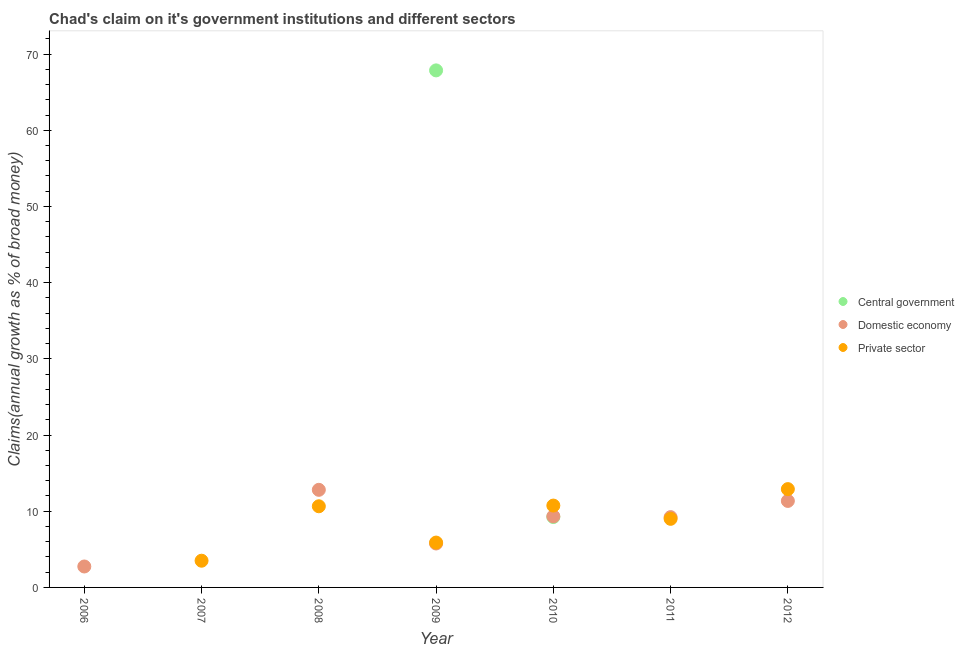Is the number of dotlines equal to the number of legend labels?
Offer a very short reply. No. Across all years, what is the maximum percentage of claim on the central government?
Make the answer very short. 67.86. In which year was the percentage of claim on the domestic economy maximum?
Offer a terse response. 2008. What is the total percentage of claim on the domestic economy in the graph?
Give a very brief answer. 51.23. What is the difference between the percentage of claim on the private sector in 2011 and that in 2012?
Your response must be concise. -3.9. What is the difference between the percentage of claim on the central government in 2010 and the percentage of claim on the domestic economy in 2008?
Your answer should be compact. -3.57. What is the average percentage of claim on the central government per year?
Give a very brief answer. 11.01. In the year 2009, what is the difference between the percentage of claim on the domestic economy and percentage of claim on the private sector?
Offer a very short reply. -0.12. In how many years, is the percentage of claim on the central government greater than 10 %?
Offer a very short reply. 1. What is the ratio of the percentage of claim on the private sector in 2008 to that in 2012?
Make the answer very short. 0.83. Is the percentage of claim on the domestic economy in 2006 less than that in 2009?
Make the answer very short. Yes. Is the difference between the percentage of claim on the domestic economy in 2009 and 2012 greater than the difference between the percentage of claim on the private sector in 2009 and 2012?
Offer a very short reply. Yes. What is the difference between the highest and the second highest percentage of claim on the domestic economy?
Your answer should be very brief. 1.46. What is the difference between the highest and the lowest percentage of claim on the central government?
Your response must be concise. 67.86. Is the percentage of claim on the domestic economy strictly greater than the percentage of claim on the private sector over the years?
Your answer should be very brief. No. Is the percentage of claim on the domestic economy strictly less than the percentage of claim on the central government over the years?
Offer a very short reply. No. What is the difference between two consecutive major ticks on the Y-axis?
Ensure brevity in your answer.  10. Where does the legend appear in the graph?
Offer a very short reply. Center right. What is the title of the graph?
Provide a short and direct response. Chad's claim on it's government institutions and different sectors. What is the label or title of the X-axis?
Offer a very short reply. Year. What is the label or title of the Y-axis?
Offer a very short reply. Claims(annual growth as % of broad money). What is the Claims(annual growth as % of broad money) of Central government in 2006?
Keep it short and to the point. 0. What is the Claims(annual growth as % of broad money) of Domestic economy in 2006?
Ensure brevity in your answer.  2.75. What is the Claims(annual growth as % of broad money) of Private sector in 2006?
Ensure brevity in your answer.  0. What is the Claims(annual growth as % of broad money) in Central government in 2007?
Your answer should be compact. 0. What is the Claims(annual growth as % of broad money) of Private sector in 2007?
Provide a succinct answer. 3.51. What is the Claims(annual growth as % of broad money) in Domestic economy in 2008?
Give a very brief answer. 12.81. What is the Claims(annual growth as % of broad money) of Private sector in 2008?
Offer a very short reply. 10.65. What is the Claims(annual growth as % of broad money) in Central government in 2009?
Provide a short and direct response. 67.86. What is the Claims(annual growth as % of broad money) in Domestic economy in 2009?
Give a very brief answer. 5.77. What is the Claims(annual growth as % of broad money) of Private sector in 2009?
Your response must be concise. 5.89. What is the Claims(annual growth as % of broad money) in Central government in 2010?
Offer a terse response. 9.24. What is the Claims(annual growth as % of broad money) of Domestic economy in 2010?
Ensure brevity in your answer.  9.33. What is the Claims(annual growth as % of broad money) of Private sector in 2010?
Give a very brief answer. 10.74. What is the Claims(annual growth as % of broad money) of Central government in 2011?
Provide a succinct answer. 0. What is the Claims(annual growth as % of broad money) in Domestic economy in 2011?
Make the answer very short. 9.22. What is the Claims(annual growth as % of broad money) in Private sector in 2011?
Offer a very short reply. 9. What is the Claims(annual growth as % of broad money) of Central government in 2012?
Your answer should be compact. 0. What is the Claims(annual growth as % of broad money) in Domestic economy in 2012?
Your answer should be very brief. 11.35. What is the Claims(annual growth as % of broad money) of Private sector in 2012?
Make the answer very short. 12.9. Across all years, what is the maximum Claims(annual growth as % of broad money) of Central government?
Give a very brief answer. 67.86. Across all years, what is the maximum Claims(annual growth as % of broad money) in Domestic economy?
Offer a very short reply. 12.81. Across all years, what is the maximum Claims(annual growth as % of broad money) in Private sector?
Your answer should be very brief. 12.9. Across all years, what is the minimum Claims(annual growth as % of broad money) in Domestic economy?
Ensure brevity in your answer.  0. What is the total Claims(annual growth as % of broad money) in Central government in the graph?
Keep it short and to the point. 77.09. What is the total Claims(annual growth as % of broad money) of Domestic economy in the graph?
Provide a succinct answer. 51.23. What is the total Claims(annual growth as % of broad money) in Private sector in the graph?
Offer a very short reply. 52.69. What is the difference between the Claims(annual growth as % of broad money) in Domestic economy in 2006 and that in 2008?
Ensure brevity in your answer.  -10.06. What is the difference between the Claims(annual growth as % of broad money) of Domestic economy in 2006 and that in 2009?
Your answer should be very brief. -3.02. What is the difference between the Claims(annual growth as % of broad money) in Domestic economy in 2006 and that in 2010?
Offer a very short reply. -6.58. What is the difference between the Claims(annual growth as % of broad money) in Domestic economy in 2006 and that in 2011?
Offer a terse response. -6.48. What is the difference between the Claims(annual growth as % of broad money) in Domestic economy in 2006 and that in 2012?
Your answer should be very brief. -8.6. What is the difference between the Claims(annual growth as % of broad money) in Private sector in 2007 and that in 2008?
Your answer should be compact. -7.14. What is the difference between the Claims(annual growth as % of broad money) in Private sector in 2007 and that in 2009?
Provide a short and direct response. -2.38. What is the difference between the Claims(annual growth as % of broad money) of Private sector in 2007 and that in 2010?
Offer a very short reply. -7.24. What is the difference between the Claims(annual growth as % of broad money) in Private sector in 2007 and that in 2011?
Offer a very short reply. -5.5. What is the difference between the Claims(annual growth as % of broad money) of Private sector in 2007 and that in 2012?
Your answer should be very brief. -9.4. What is the difference between the Claims(annual growth as % of broad money) in Domestic economy in 2008 and that in 2009?
Your response must be concise. 7.04. What is the difference between the Claims(annual growth as % of broad money) of Private sector in 2008 and that in 2009?
Ensure brevity in your answer.  4.76. What is the difference between the Claims(annual growth as % of broad money) in Domestic economy in 2008 and that in 2010?
Provide a succinct answer. 3.48. What is the difference between the Claims(annual growth as % of broad money) in Private sector in 2008 and that in 2010?
Give a very brief answer. -0.09. What is the difference between the Claims(annual growth as % of broad money) in Domestic economy in 2008 and that in 2011?
Offer a terse response. 3.59. What is the difference between the Claims(annual growth as % of broad money) in Private sector in 2008 and that in 2011?
Ensure brevity in your answer.  1.65. What is the difference between the Claims(annual growth as % of broad money) in Domestic economy in 2008 and that in 2012?
Give a very brief answer. 1.46. What is the difference between the Claims(annual growth as % of broad money) in Private sector in 2008 and that in 2012?
Your response must be concise. -2.25. What is the difference between the Claims(annual growth as % of broad money) of Central government in 2009 and that in 2010?
Ensure brevity in your answer.  58.62. What is the difference between the Claims(annual growth as % of broad money) of Domestic economy in 2009 and that in 2010?
Offer a very short reply. -3.56. What is the difference between the Claims(annual growth as % of broad money) of Private sector in 2009 and that in 2010?
Provide a succinct answer. -4.86. What is the difference between the Claims(annual growth as % of broad money) of Domestic economy in 2009 and that in 2011?
Keep it short and to the point. -3.46. What is the difference between the Claims(annual growth as % of broad money) of Private sector in 2009 and that in 2011?
Offer a very short reply. -3.12. What is the difference between the Claims(annual growth as % of broad money) of Domestic economy in 2009 and that in 2012?
Offer a terse response. -5.59. What is the difference between the Claims(annual growth as % of broad money) in Private sector in 2009 and that in 2012?
Make the answer very short. -7.02. What is the difference between the Claims(annual growth as % of broad money) in Domestic economy in 2010 and that in 2011?
Keep it short and to the point. 0.11. What is the difference between the Claims(annual growth as % of broad money) in Private sector in 2010 and that in 2011?
Keep it short and to the point. 1.74. What is the difference between the Claims(annual growth as % of broad money) in Domestic economy in 2010 and that in 2012?
Ensure brevity in your answer.  -2.02. What is the difference between the Claims(annual growth as % of broad money) of Private sector in 2010 and that in 2012?
Keep it short and to the point. -2.16. What is the difference between the Claims(annual growth as % of broad money) of Domestic economy in 2011 and that in 2012?
Your answer should be very brief. -2.13. What is the difference between the Claims(annual growth as % of broad money) of Private sector in 2011 and that in 2012?
Your response must be concise. -3.9. What is the difference between the Claims(annual growth as % of broad money) in Domestic economy in 2006 and the Claims(annual growth as % of broad money) in Private sector in 2007?
Ensure brevity in your answer.  -0.76. What is the difference between the Claims(annual growth as % of broad money) of Domestic economy in 2006 and the Claims(annual growth as % of broad money) of Private sector in 2008?
Provide a short and direct response. -7.9. What is the difference between the Claims(annual growth as % of broad money) in Domestic economy in 2006 and the Claims(annual growth as % of broad money) in Private sector in 2009?
Give a very brief answer. -3.14. What is the difference between the Claims(annual growth as % of broad money) in Domestic economy in 2006 and the Claims(annual growth as % of broad money) in Private sector in 2010?
Offer a very short reply. -7.99. What is the difference between the Claims(annual growth as % of broad money) of Domestic economy in 2006 and the Claims(annual growth as % of broad money) of Private sector in 2011?
Offer a terse response. -6.25. What is the difference between the Claims(annual growth as % of broad money) in Domestic economy in 2006 and the Claims(annual growth as % of broad money) in Private sector in 2012?
Keep it short and to the point. -10.15. What is the difference between the Claims(annual growth as % of broad money) in Domestic economy in 2008 and the Claims(annual growth as % of broad money) in Private sector in 2009?
Provide a short and direct response. 6.92. What is the difference between the Claims(annual growth as % of broad money) in Domestic economy in 2008 and the Claims(annual growth as % of broad money) in Private sector in 2010?
Your response must be concise. 2.07. What is the difference between the Claims(annual growth as % of broad money) in Domestic economy in 2008 and the Claims(annual growth as % of broad money) in Private sector in 2011?
Provide a short and direct response. 3.81. What is the difference between the Claims(annual growth as % of broad money) in Domestic economy in 2008 and the Claims(annual growth as % of broad money) in Private sector in 2012?
Your response must be concise. -0.09. What is the difference between the Claims(annual growth as % of broad money) in Central government in 2009 and the Claims(annual growth as % of broad money) in Domestic economy in 2010?
Make the answer very short. 58.53. What is the difference between the Claims(annual growth as % of broad money) in Central government in 2009 and the Claims(annual growth as % of broad money) in Private sector in 2010?
Provide a short and direct response. 57.11. What is the difference between the Claims(annual growth as % of broad money) of Domestic economy in 2009 and the Claims(annual growth as % of broad money) of Private sector in 2010?
Your answer should be compact. -4.98. What is the difference between the Claims(annual growth as % of broad money) in Central government in 2009 and the Claims(annual growth as % of broad money) in Domestic economy in 2011?
Keep it short and to the point. 58.63. What is the difference between the Claims(annual growth as % of broad money) of Central government in 2009 and the Claims(annual growth as % of broad money) of Private sector in 2011?
Provide a short and direct response. 58.85. What is the difference between the Claims(annual growth as % of broad money) of Domestic economy in 2009 and the Claims(annual growth as % of broad money) of Private sector in 2011?
Your response must be concise. -3.24. What is the difference between the Claims(annual growth as % of broad money) of Central government in 2009 and the Claims(annual growth as % of broad money) of Domestic economy in 2012?
Give a very brief answer. 56.5. What is the difference between the Claims(annual growth as % of broad money) in Central government in 2009 and the Claims(annual growth as % of broad money) in Private sector in 2012?
Provide a succinct answer. 54.95. What is the difference between the Claims(annual growth as % of broad money) of Domestic economy in 2009 and the Claims(annual growth as % of broad money) of Private sector in 2012?
Offer a terse response. -7.14. What is the difference between the Claims(annual growth as % of broad money) in Central government in 2010 and the Claims(annual growth as % of broad money) in Domestic economy in 2011?
Your response must be concise. 0.01. What is the difference between the Claims(annual growth as % of broad money) of Central government in 2010 and the Claims(annual growth as % of broad money) of Private sector in 2011?
Give a very brief answer. 0.24. What is the difference between the Claims(annual growth as % of broad money) in Domestic economy in 2010 and the Claims(annual growth as % of broad money) in Private sector in 2011?
Make the answer very short. 0.33. What is the difference between the Claims(annual growth as % of broad money) of Central government in 2010 and the Claims(annual growth as % of broad money) of Domestic economy in 2012?
Keep it short and to the point. -2.11. What is the difference between the Claims(annual growth as % of broad money) in Central government in 2010 and the Claims(annual growth as % of broad money) in Private sector in 2012?
Give a very brief answer. -3.66. What is the difference between the Claims(annual growth as % of broad money) in Domestic economy in 2010 and the Claims(annual growth as % of broad money) in Private sector in 2012?
Your answer should be very brief. -3.57. What is the difference between the Claims(annual growth as % of broad money) in Domestic economy in 2011 and the Claims(annual growth as % of broad money) in Private sector in 2012?
Keep it short and to the point. -3.68. What is the average Claims(annual growth as % of broad money) in Central government per year?
Offer a terse response. 11.01. What is the average Claims(annual growth as % of broad money) in Domestic economy per year?
Provide a succinct answer. 7.32. What is the average Claims(annual growth as % of broad money) of Private sector per year?
Provide a succinct answer. 7.53. In the year 2008, what is the difference between the Claims(annual growth as % of broad money) of Domestic economy and Claims(annual growth as % of broad money) of Private sector?
Provide a short and direct response. 2.16. In the year 2009, what is the difference between the Claims(annual growth as % of broad money) of Central government and Claims(annual growth as % of broad money) of Domestic economy?
Give a very brief answer. 62.09. In the year 2009, what is the difference between the Claims(annual growth as % of broad money) of Central government and Claims(annual growth as % of broad money) of Private sector?
Offer a very short reply. 61.97. In the year 2009, what is the difference between the Claims(annual growth as % of broad money) in Domestic economy and Claims(annual growth as % of broad money) in Private sector?
Offer a very short reply. -0.12. In the year 2010, what is the difference between the Claims(annual growth as % of broad money) of Central government and Claims(annual growth as % of broad money) of Domestic economy?
Give a very brief answer. -0.09. In the year 2010, what is the difference between the Claims(annual growth as % of broad money) of Central government and Claims(annual growth as % of broad money) of Private sector?
Give a very brief answer. -1.5. In the year 2010, what is the difference between the Claims(annual growth as % of broad money) of Domestic economy and Claims(annual growth as % of broad money) of Private sector?
Provide a succinct answer. -1.41. In the year 2011, what is the difference between the Claims(annual growth as % of broad money) of Domestic economy and Claims(annual growth as % of broad money) of Private sector?
Your answer should be very brief. 0.22. In the year 2012, what is the difference between the Claims(annual growth as % of broad money) in Domestic economy and Claims(annual growth as % of broad money) in Private sector?
Ensure brevity in your answer.  -1.55. What is the ratio of the Claims(annual growth as % of broad money) in Domestic economy in 2006 to that in 2008?
Provide a short and direct response. 0.21. What is the ratio of the Claims(annual growth as % of broad money) in Domestic economy in 2006 to that in 2009?
Keep it short and to the point. 0.48. What is the ratio of the Claims(annual growth as % of broad money) in Domestic economy in 2006 to that in 2010?
Your answer should be compact. 0.29. What is the ratio of the Claims(annual growth as % of broad money) in Domestic economy in 2006 to that in 2011?
Give a very brief answer. 0.3. What is the ratio of the Claims(annual growth as % of broad money) in Domestic economy in 2006 to that in 2012?
Your response must be concise. 0.24. What is the ratio of the Claims(annual growth as % of broad money) in Private sector in 2007 to that in 2008?
Offer a terse response. 0.33. What is the ratio of the Claims(annual growth as % of broad money) in Private sector in 2007 to that in 2009?
Offer a very short reply. 0.6. What is the ratio of the Claims(annual growth as % of broad money) in Private sector in 2007 to that in 2010?
Your response must be concise. 0.33. What is the ratio of the Claims(annual growth as % of broad money) of Private sector in 2007 to that in 2011?
Provide a short and direct response. 0.39. What is the ratio of the Claims(annual growth as % of broad money) in Private sector in 2007 to that in 2012?
Give a very brief answer. 0.27. What is the ratio of the Claims(annual growth as % of broad money) of Domestic economy in 2008 to that in 2009?
Your answer should be very brief. 2.22. What is the ratio of the Claims(annual growth as % of broad money) of Private sector in 2008 to that in 2009?
Make the answer very short. 1.81. What is the ratio of the Claims(annual growth as % of broad money) of Domestic economy in 2008 to that in 2010?
Your response must be concise. 1.37. What is the ratio of the Claims(annual growth as % of broad money) in Domestic economy in 2008 to that in 2011?
Offer a terse response. 1.39. What is the ratio of the Claims(annual growth as % of broad money) in Private sector in 2008 to that in 2011?
Offer a very short reply. 1.18. What is the ratio of the Claims(annual growth as % of broad money) of Domestic economy in 2008 to that in 2012?
Provide a succinct answer. 1.13. What is the ratio of the Claims(annual growth as % of broad money) of Private sector in 2008 to that in 2012?
Offer a very short reply. 0.83. What is the ratio of the Claims(annual growth as % of broad money) of Central government in 2009 to that in 2010?
Give a very brief answer. 7.34. What is the ratio of the Claims(annual growth as % of broad money) in Domestic economy in 2009 to that in 2010?
Offer a very short reply. 0.62. What is the ratio of the Claims(annual growth as % of broad money) in Private sector in 2009 to that in 2010?
Keep it short and to the point. 0.55. What is the ratio of the Claims(annual growth as % of broad money) of Domestic economy in 2009 to that in 2011?
Offer a very short reply. 0.63. What is the ratio of the Claims(annual growth as % of broad money) in Private sector in 2009 to that in 2011?
Ensure brevity in your answer.  0.65. What is the ratio of the Claims(annual growth as % of broad money) of Domestic economy in 2009 to that in 2012?
Your response must be concise. 0.51. What is the ratio of the Claims(annual growth as % of broad money) of Private sector in 2009 to that in 2012?
Offer a terse response. 0.46. What is the ratio of the Claims(annual growth as % of broad money) in Domestic economy in 2010 to that in 2011?
Provide a succinct answer. 1.01. What is the ratio of the Claims(annual growth as % of broad money) of Private sector in 2010 to that in 2011?
Offer a very short reply. 1.19. What is the ratio of the Claims(annual growth as % of broad money) in Domestic economy in 2010 to that in 2012?
Provide a short and direct response. 0.82. What is the ratio of the Claims(annual growth as % of broad money) of Private sector in 2010 to that in 2012?
Provide a succinct answer. 0.83. What is the ratio of the Claims(annual growth as % of broad money) in Domestic economy in 2011 to that in 2012?
Provide a succinct answer. 0.81. What is the ratio of the Claims(annual growth as % of broad money) in Private sector in 2011 to that in 2012?
Provide a short and direct response. 0.7. What is the difference between the highest and the second highest Claims(annual growth as % of broad money) of Domestic economy?
Offer a very short reply. 1.46. What is the difference between the highest and the second highest Claims(annual growth as % of broad money) in Private sector?
Your response must be concise. 2.16. What is the difference between the highest and the lowest Claims(annual growth as % of broad money) of Central government?
Provide a short and direct response. 67.86. What is the difference between the highest and the lowest Claims(annual growth as % of broad money) in Domestic economy?
Keep it short and to the point. 12.81. What is the difference between the highest and the lowest Claims(annual growth as % of broad money) of Private sector?
Offer a very short reply. 12.9. 